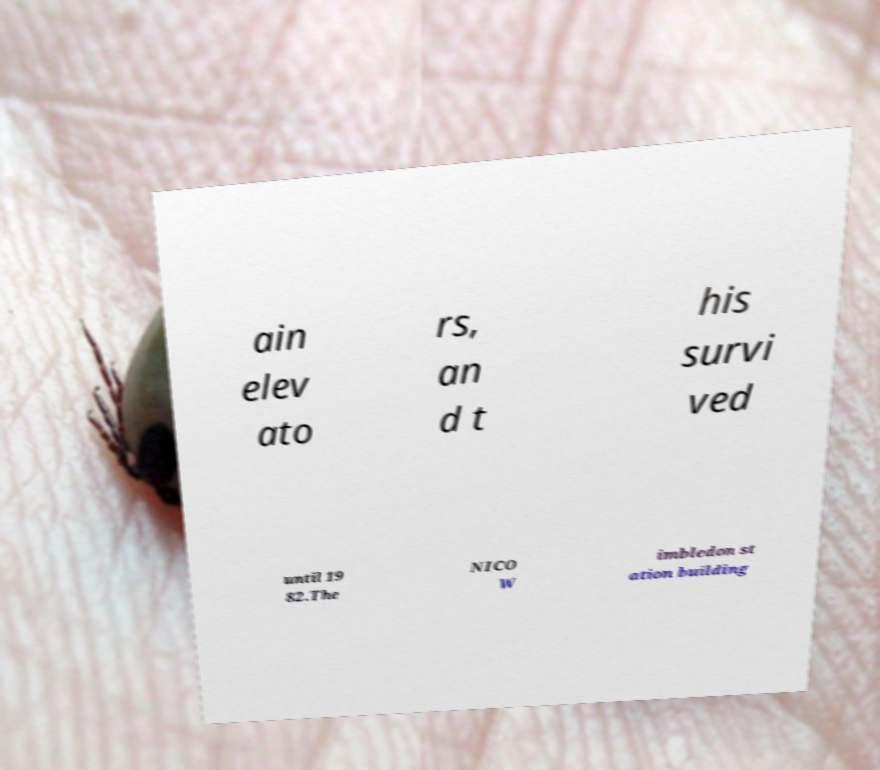Please identify and transcribe the text found in this image. ain elev ato rs, an d t his survi ved until 19 82.The NICO W imbledon st ation building 